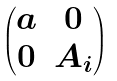<formula> <loc_0><loc_0><loc_500><loc_500>\begin{pmatrix} a & 0 \\ 0 & A _ { i } \end{pmatrix}</formula> 